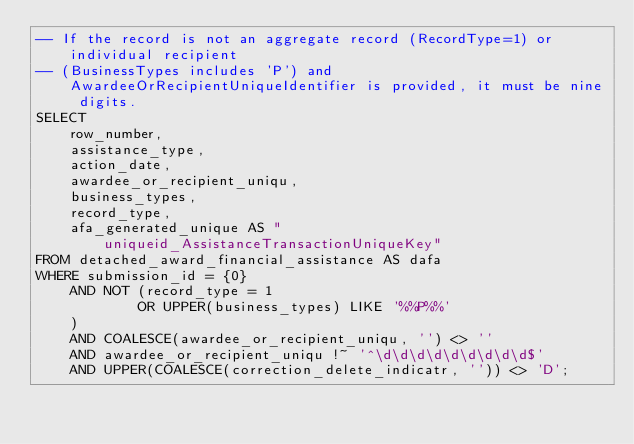<code> <loc_0><loc_0><loc_500><loc_500><_SQL_>-- If the record is not an aggregate record (RecordType=1) or individual recipient
-- (BusinessTypes includes 'P') and AwardeeOrRecipientUniqueIdentifier is provided, it must be nine digits.
SELECT
    row_number,
    assistance_type,
    action_date,
    awardee_or_recipient_uniqu,
    business_types,
    record_type,
    afa_generated_unique AS "uniqueid_AssistanceTransactionUniqueKey"
FROM detached_award_financial_assistance AS dafa
WHERE submission_id = {0}
    AND NOT (record_type = 1
            OR UPPER(business_types) LIKE '%%P%%'
    )
    AND COALESCE(awardee_or_recipient_uniqu, '') <> ''
    AND awardee_or_recipient_uniqu !~ '^\d\d\d\d\d\d\d\d\d$'
    AND UPPER(COALESCE(correction_delete_indicatr, '')) <> 'D';
</code> 